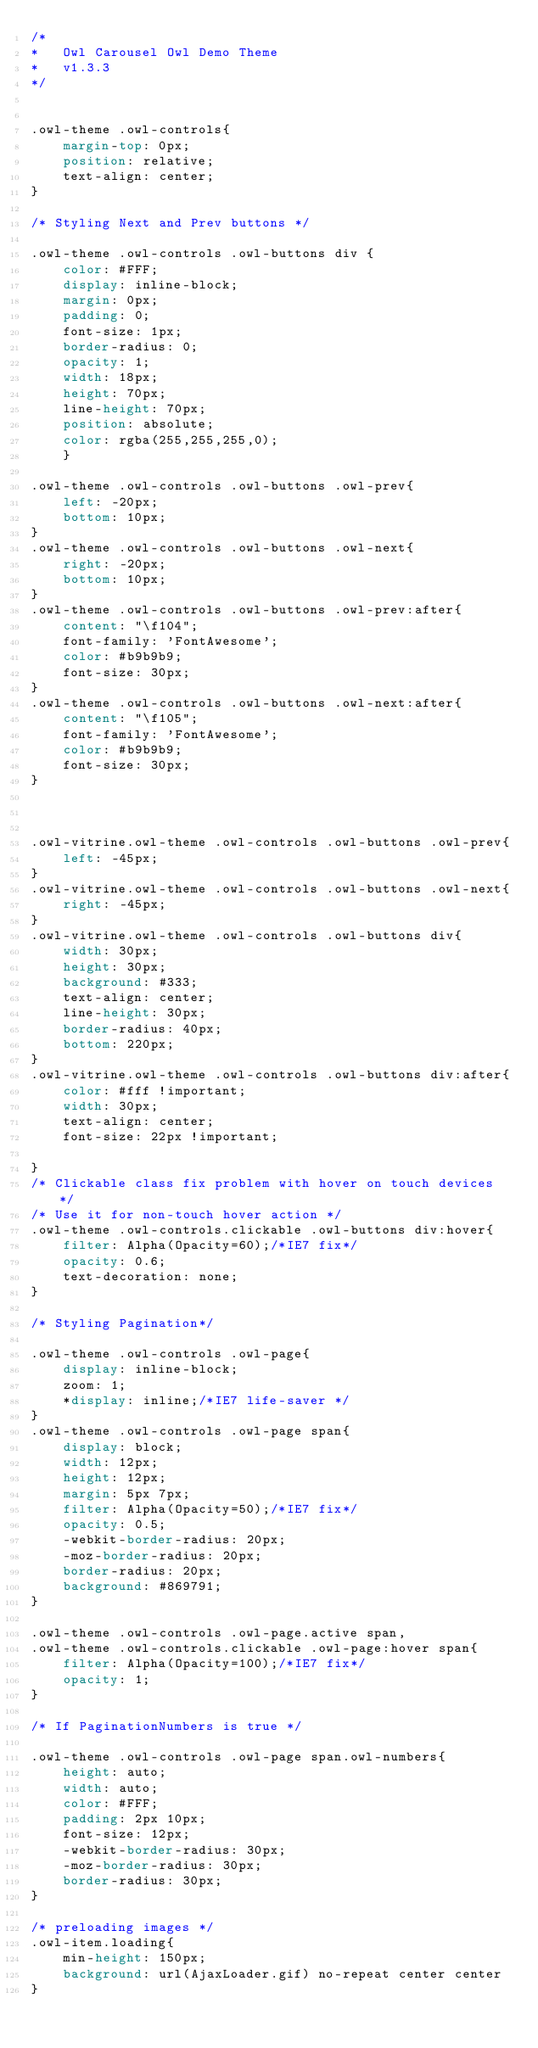Convert code to text. <code><loc_0><loc_0><loc_500><loc_500><_CSS_>/*
* 	Owl Carousel Owl Demo Theme 
*	v1.3.3
*/


.owl-theme .owl-controls{
    margin-top: 0px;
    position: relative;
    text-align: center;
}

/* Styling Next and Prev buttons */

.owl-theme .owl-controls .owl-buttons div {
    color: #FFF;
    display: inline-block;
    margin: 0px;
    padding: 0;
    font-size: 1px;
    border-radius: 0;
    opacity: 1;
    width: 18px;
    height: 70px;
    line-height: 70px;
    position: absolute;
    color: rgba(255,255,255,0);
    }

.owl-theme .owl-controls .owl-buttons .owl-prev{
    left: -20px;
    bottom: 10px;
}
.owl-theme .owl-controls .owl-buttons .owl-next{
    right: -20px;
    bottom: 10px;
}
.owl-theme .owl-controls .owl-buttons .owl-prev:after{
    content: "\f104";
    font-family: 'FontAwesome';
    color: #b9b9b9;
    font-size: 30px;
}
.owl-theme .owl-controls .owl-buttons .owl-next:after{
    content: "\f105";
    font-family: 'FontAwesome';
    color: #b9b9b9;
    font-size: 30px;
}



.owl-vitrine.owl-theme .owl-controls .owl-buttons .owl-prev{
    left: -45px;
}
.owl-vitrine.owl-theme .owl-controls .owl-buttons .owl-next{
    right: -45px;
}
.owl-vitrine.owl-theme .owl-controls .owl-buttons div{
	width: 30px;
	height: 30px;
	background: #333;
	text-align: center;
	line-height: 30px;
	border-radius: 40px;
	bottom: 220px;
}
.owl-vitrine.owl-theme .owl-controls .owl-buttons div:after{
    color: #fff !important;
    width: 30px;
    text-align: center;
    font-size: 22px !important;

}
/* Clickable class fix problem with hover on touch devices */
/* Use it for non-touch hover action */
.owl-theme .owl-controls.clickable .owl-buttons div:hover{
	filter: Alpha(Opacity=60);/*IE7 fix*/
	opacity: 0.6;
	text-decoration: none;
}

/* Styling Pagination*/

.owl-theme .owl-controls .owl-page{
	display: inline-block;
	zoom: 1;
	*display: inline;/*IE7 life-saver */
}
.owl-theme .owl-controls .owl-page span{
	display: block;
	width: 12px;
	height: 12px;
	margin: 5px 7px;
	filter: Alpha(Opacity=50);/*IE7 fix*/
	opacity: 0.5;
	-webkit-border-radius: 20px;
	-moz-border-radius: 20px;
	border-radius: 20px;
	background: #869791;
}

.owl-theme .owl-controls .owl-page.active span,
.owl-theme .owl-controls.clickable .owl-page:hover span{
	filter: Alpha(Opacity=100);/*IE7 fix*/
	opacity: 1;
}

/* If PaginationNumbers is true */

.owl-theme .owl-controls .owl-page span.owl-numbers{
	height: auto;
	width: auto;
	color: #FFF;
	padding: 2px 10px;
	font-size: 12px;
	-webkit-border-radius: 30px;
	-moz-border-radius: 30px;
	border-radius: 30px;
}

/* preloading images */
.owl-item.loading{
	min-height: 150px;
	background: url(AjaxLoader.gif) no-repeat center center
}</code> 